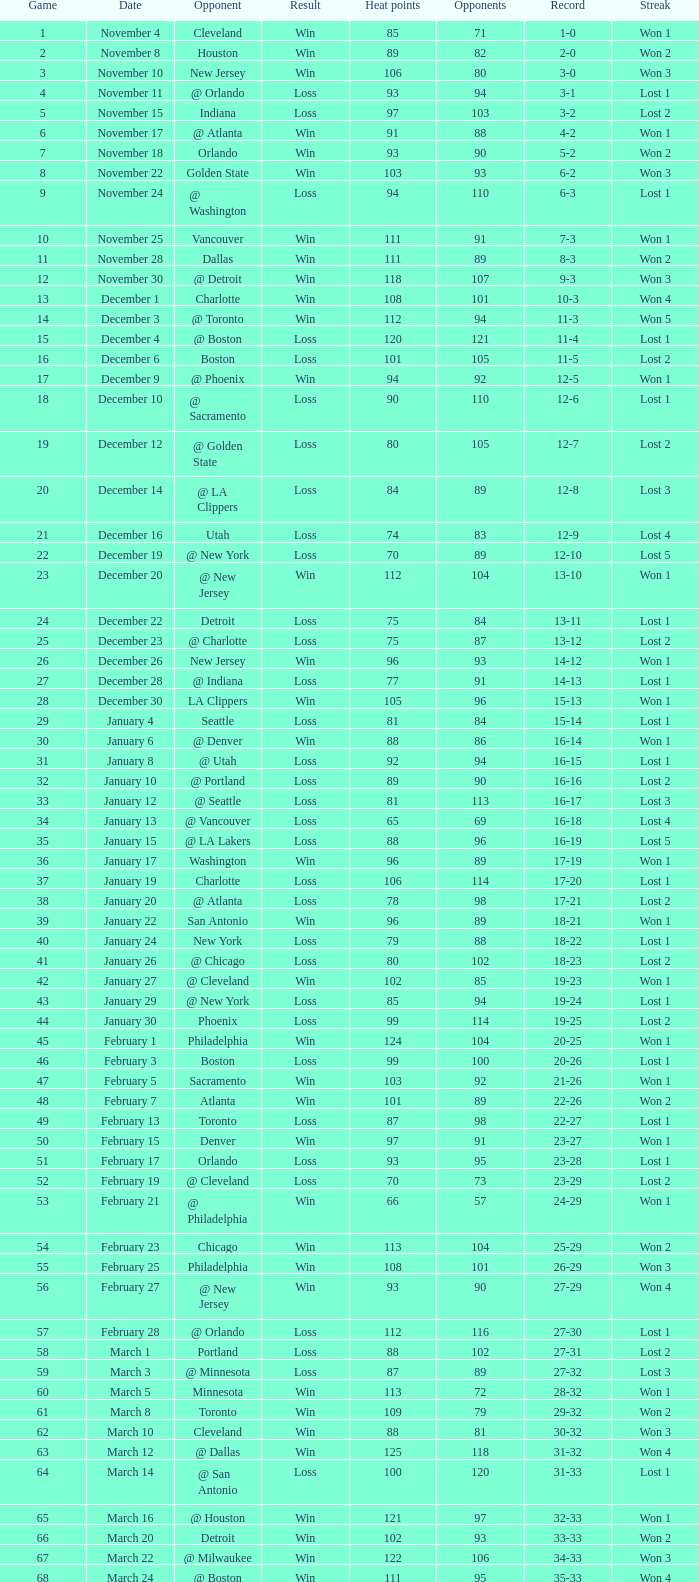What is the highest Game, when Opponents is less than 80, and when Record is "1-0"? 1.0. 